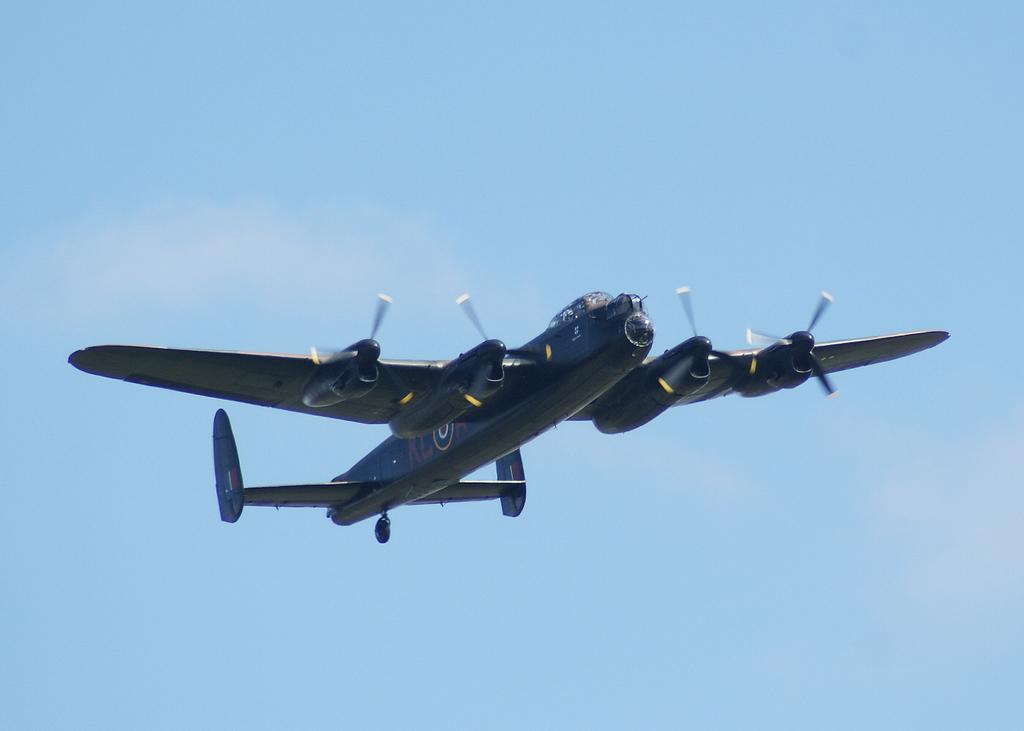What is the main subject of the image? The main subject of the image is an airplane. What is the airplane doing in the image? The airplane is flying in the sky. How does the airplane breathe while flying in the image? Airplanes do not breathe; they are machines that fly using engines and lift generated by their wings. What type of wrench is being used by the airplane in the image? There is no wrench present in the image, as airplanes are not operated using wrenches. 